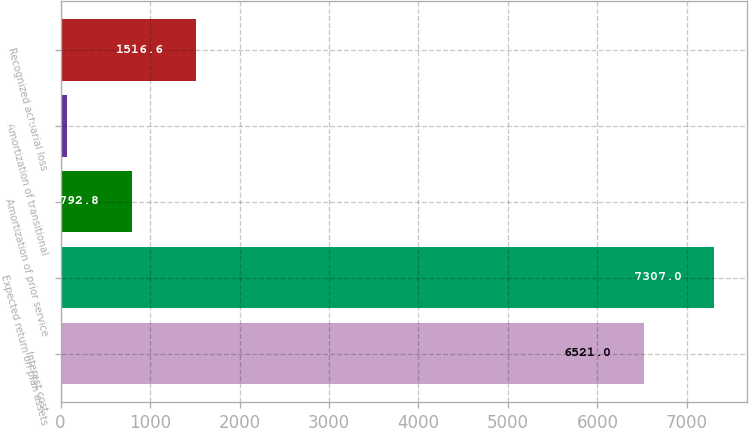Convert chart. <chart><loc_0><loc_0><loc_500><loc_500><bar_chart><fcel>Interest cost<fcel>Expected return on plan assets<fcel>Amortization of prior service<fcel>Amortization of transitional<fcel>Recognized actuarial loss<nl><fcel>6521<fcel>7307<fcel>792.8<fcel>69<fcel>1516.6<nl></chart> 